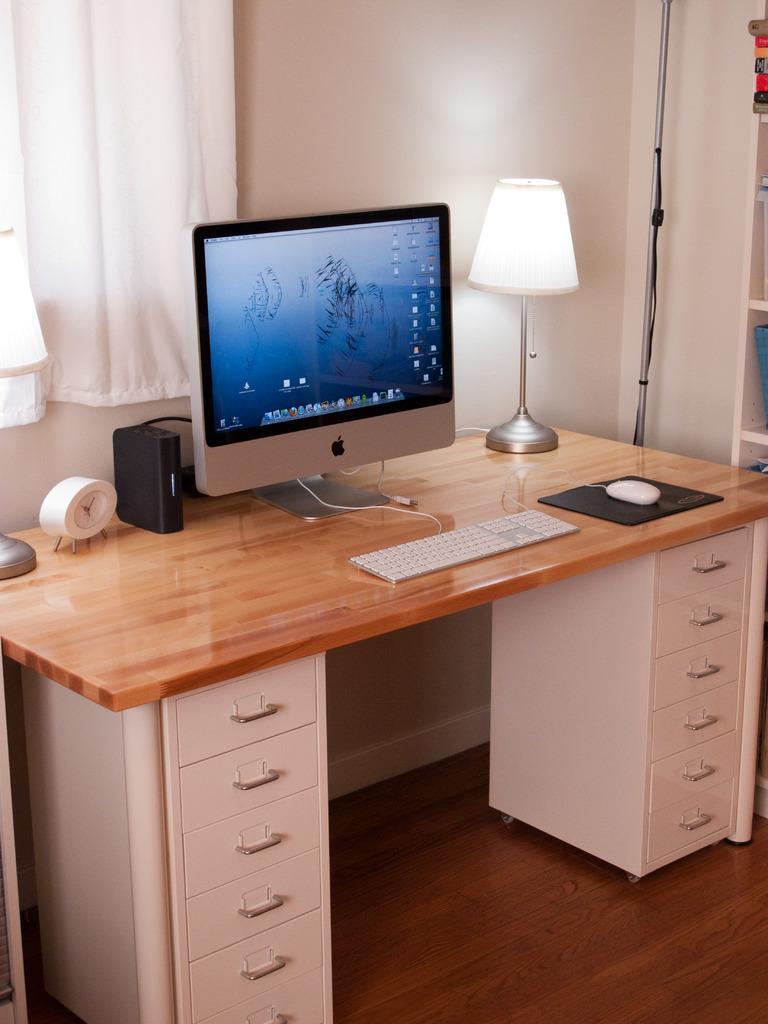Describe this image in one or two sentences. The image is inside the room. In the image there is a table, on table we can see a keyboard,mouse,monitor,speaker,clock,lamp on left side there is a curtain and right side there is a shelf in background there is a wall which is in white color. 